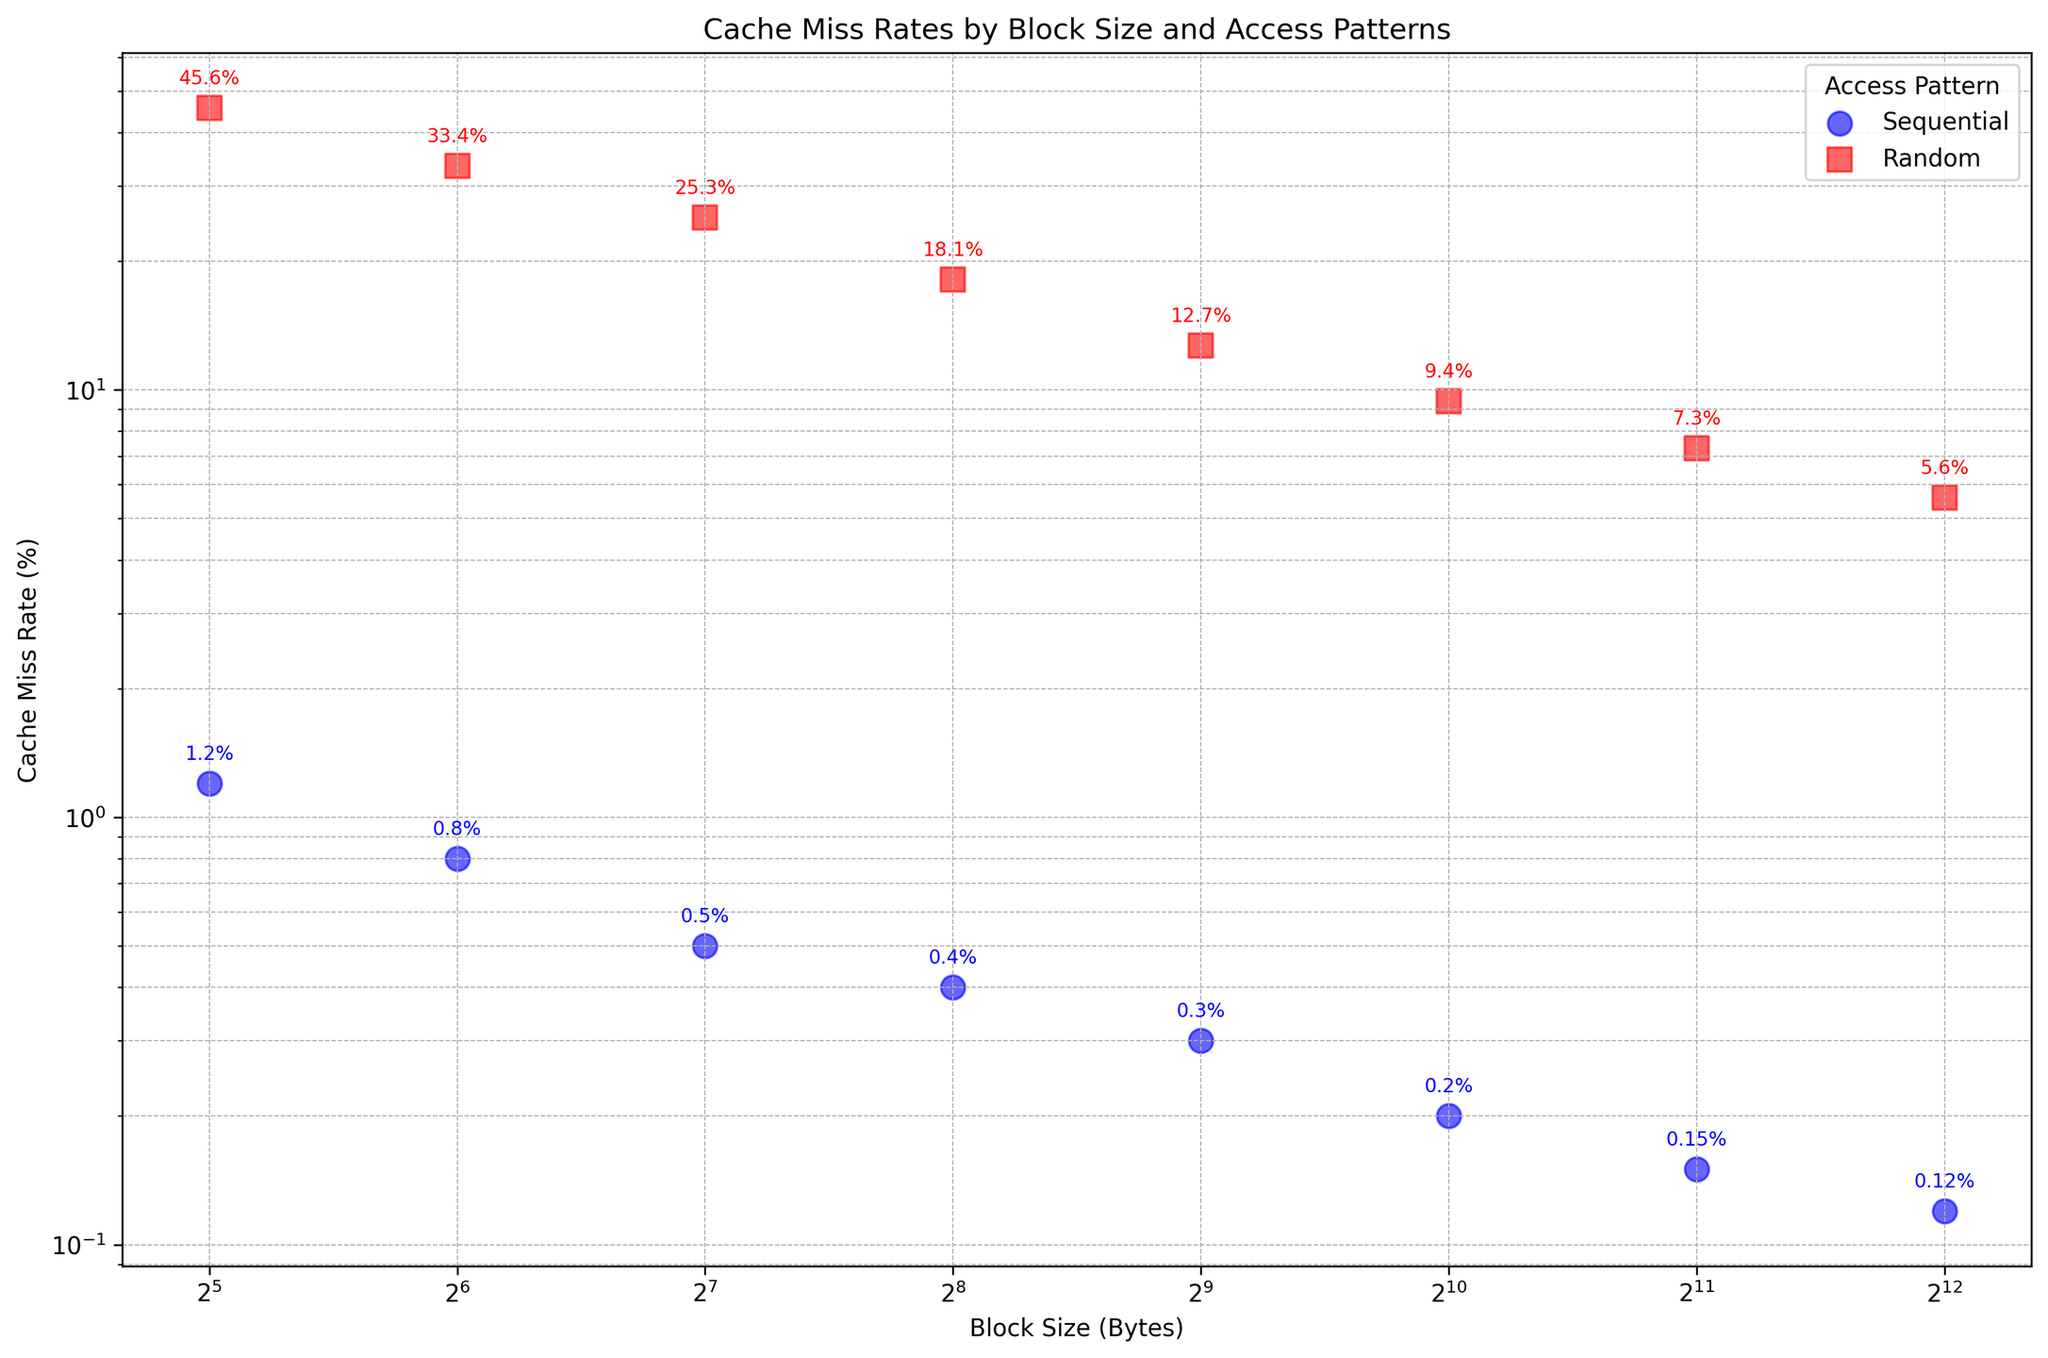How does the cache miss rate for sequential access patterns change as the block size increases? The cache miss rate for sequential access patterns decreases as the block size increases. This can be observed as the blue dots representing sequential access show lower cache miss rates as we move to the right (increasing block size) on the x-axis.
Answer: Decreases Which access pattern has a higher cache miss rate at a block size of 64 bytes? By comparing the points at 64 bytes, the red square (Random access) is at 33.4%, which is higher than the blue circle (Sequential access) at 0.8%.
Answer: Random What's the difference in cache miss rates between sequential and random access at a block size of 256 bytes? For sequential access at 256 bytes, the cache miss rate is 0.4%, and for random access, it is 18.1%. The difference is 18.1% - 0.4% = 17.7%.
Answer: 17.7% Is there a point where the cache miss rate for sequential access exceeds 1%? Observing the blue circles representing sequential access values, the highest miss rate is 1.2% at 32 bytes.
Answer: Yes, at 32 bytes At which block sizes do the cache miss rates for sequential access fall below 0.2%? For sequential access, the block sizes with cache miss rates below 0.2% are 1024, 2048, and 4096 bytes.
Answer: 1024, 2048, 4096 bytes How does the cache miss rate for random access change between 32 bytes and 4096 bytes? The cache miss rate for random access decreases from 45.6% at 32 bytes to 5.6% at 4096 bytes.
Answer: Decreases Which access pattern's cache miss rate shows a logarithmic trend as the block size increases? The graph shows a logarithmic scale on both axes. For both access patterns, however, it's clear random access (red squares) has a distinct logarithmic decrease in cache miss rate as the block size increases.
Answer: Random How much lower is the cache miss rate for sequential access at 512 bytes compared to random access at the same block size? The cache miss rate for sequential access at 512 bytes is 0.3%, while for random access it is 12.7%. The difference is 12.7% - 0.3% = 12.4%.
Answer: 12.4% What is the average cache miss rate for random access patterns across all block sizes? The cache miss rates for random access at each block size are: 45.6%, 33.4%, 25.3%, 18.1%, 12.7%, 9.4%, 7.3%, 5.6%. Summing these gives 157.4%, and there are 8 values. The average is 157.4% / 8 = 19.675%.
Answer: 19.7% Which access pattern is more affected by changes in block size? Random access patterns show a significant decrease in cache miss rates across different block sizes compared to the more stable rates for sequential access. This can be observed by the larger spread of the red squares.
Answer: Random 